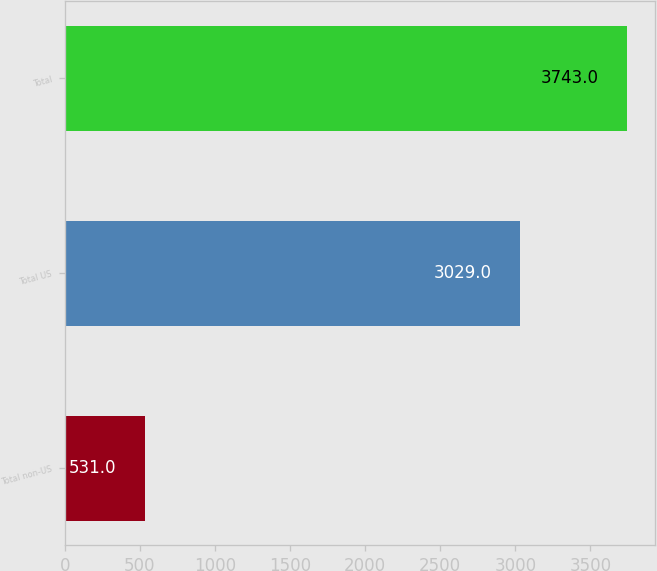Convert chart. <chart><loc_0><loc_0><loc_500><loc_500><bar_chart><fcel>Total non-US<fcel>Total US<fcel>Total<nl><fcel>531<fcel>3029<fcel>3743<nl></chart> 